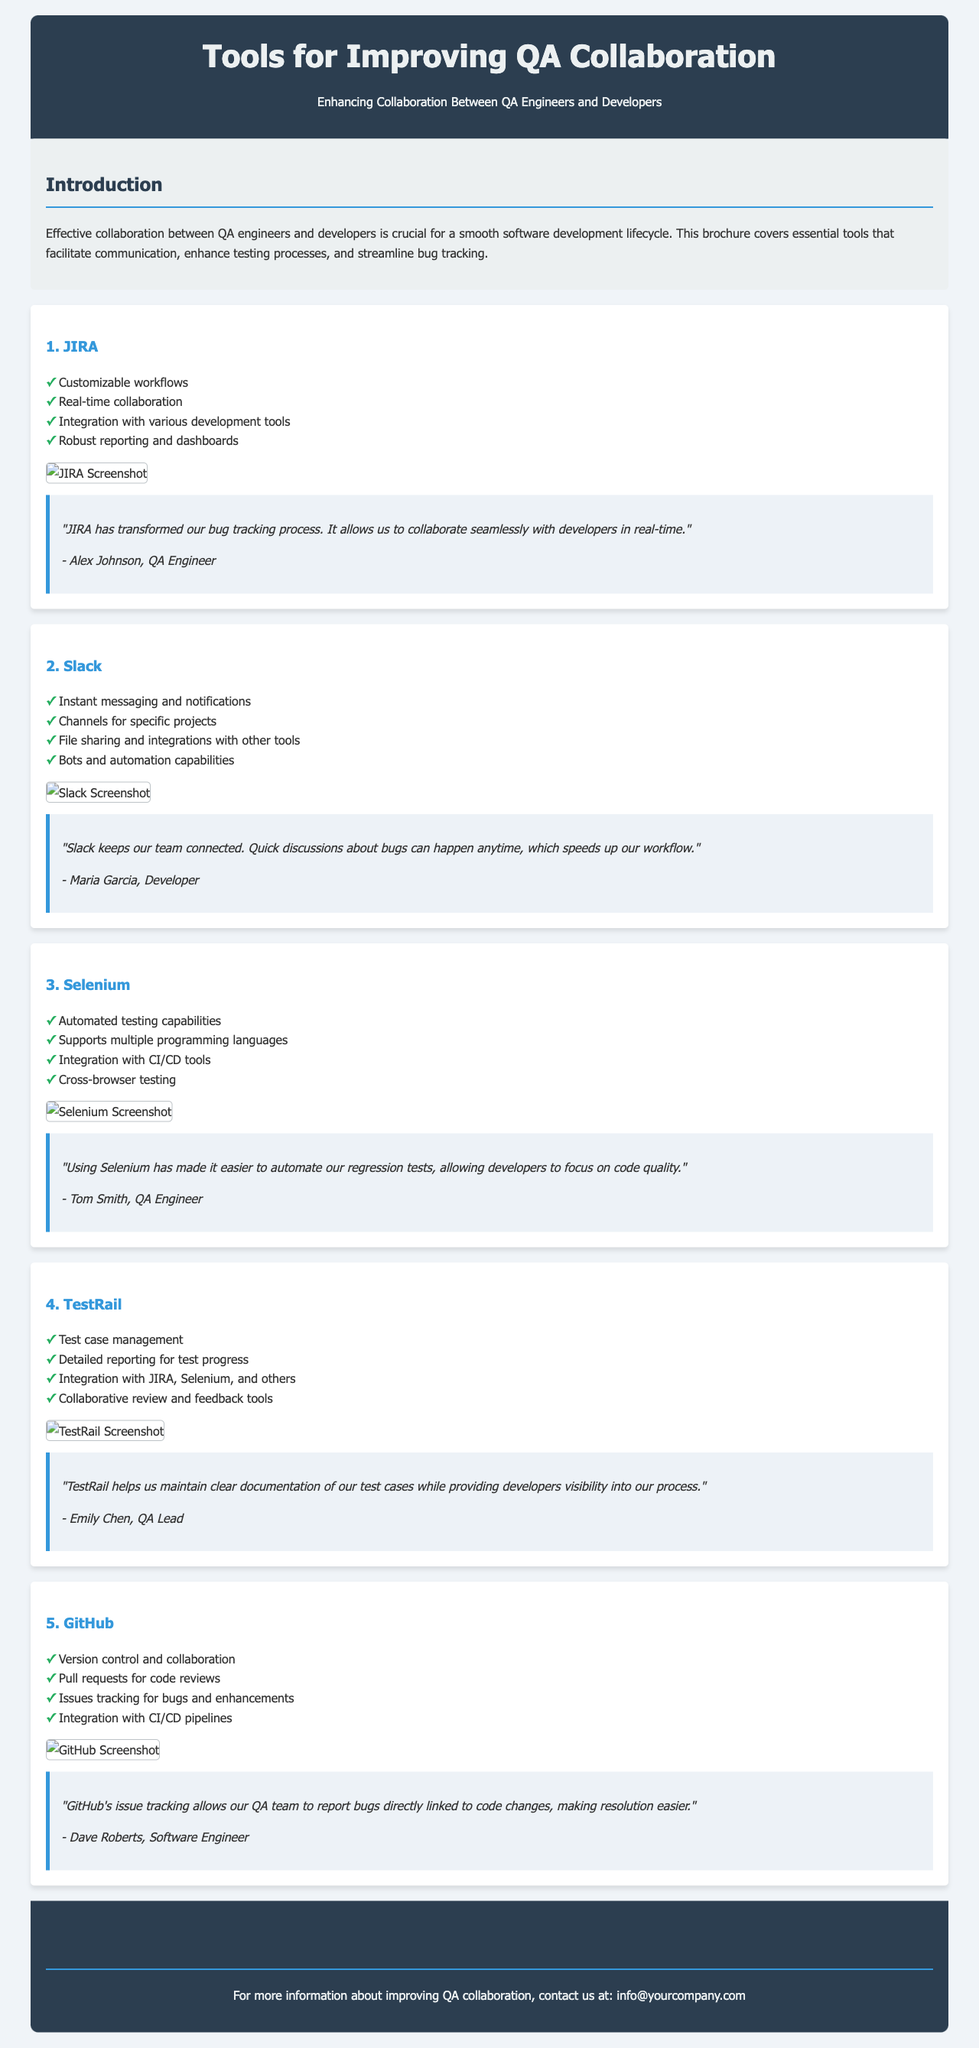What is the title of the document? The title of the document is indicated in the header section, which clearly displays the main topic of the brochure.
Answer: Tools for Improving QA Collaboration How many tools are highlighted in the brochure? The brochure lists and describes five distinct tools that aid in QA collaboration.
Answer: Five Who is the author of the testimonial for JIRA? The testimonial for JIRA includes the name of the user providing feedback, which helps to personalize the experience.
Answer: Alex Johnson What feature does GitHub provide for tracking bugs? GitHub’s role in issue tracking enhances the collaboration and resolution of bugs as indicated in the features list.
Answer: Issues tracking Which tool is associated with automated testing capabilities? The tools described in the document offer specific functionalities that cater to different aspects, such as automation in testing.
Answer: Selenium What color is used for the header background? The header background color is specified in the design section, contributing to the visual appeal of the document.
Answer: Dark blue Which feature allows for real-time collaboration in JIRA? The specific feature mentioned highlights how JIRA supports live interaction between QA engineers and developers.
Answer: Real-time collaboration Who provided the testimonial for Slack? The document includes testimonials from various users, indicating their experiences with the tools listed, including Slack.
Answer: Maria Garcia 